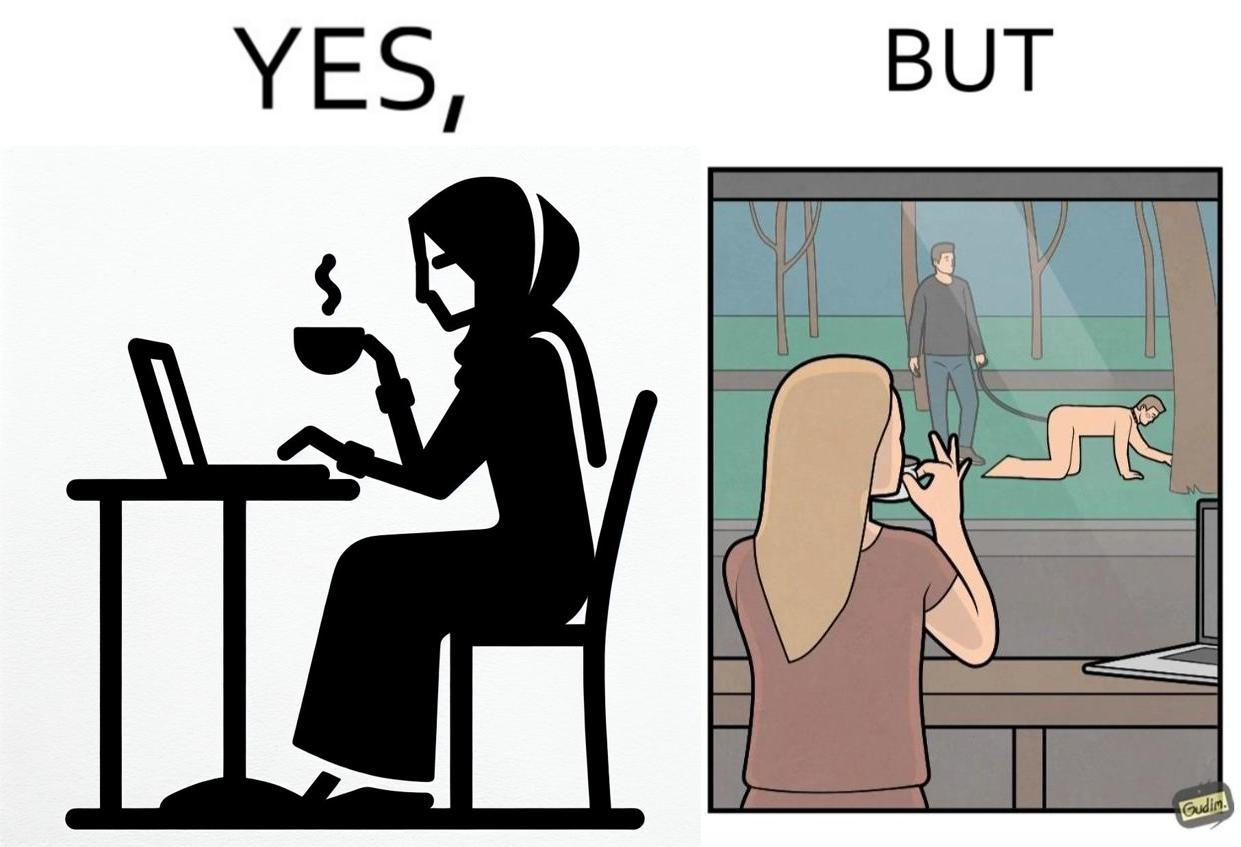What is the satirical meaning behind this image? The image is ironic, because in the first image a woman is seen enjoying her coffee, while watching the injustice happening outside without even having a single thought on the injustice outside and taking some actions or raising some concerns over it 